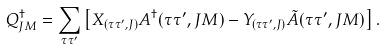<formula> <loc_0><loc_0><loc_500><loc_500>Q ^ { \dagger } _ { J M } = \sum _ { \tau \tau ^ { \prime } } \left [ X _ { ( \tau \tau ^ { \prime } , J ) } A ^ { \dagger } ( \tau \tau ^ { \prime } , J M ) - Y _ { ( \tau \tau ^ { \prime } , J ) } \tilde { A } ( \tau \tau ^ { \prime } , J M ) \right ] .</formula> 